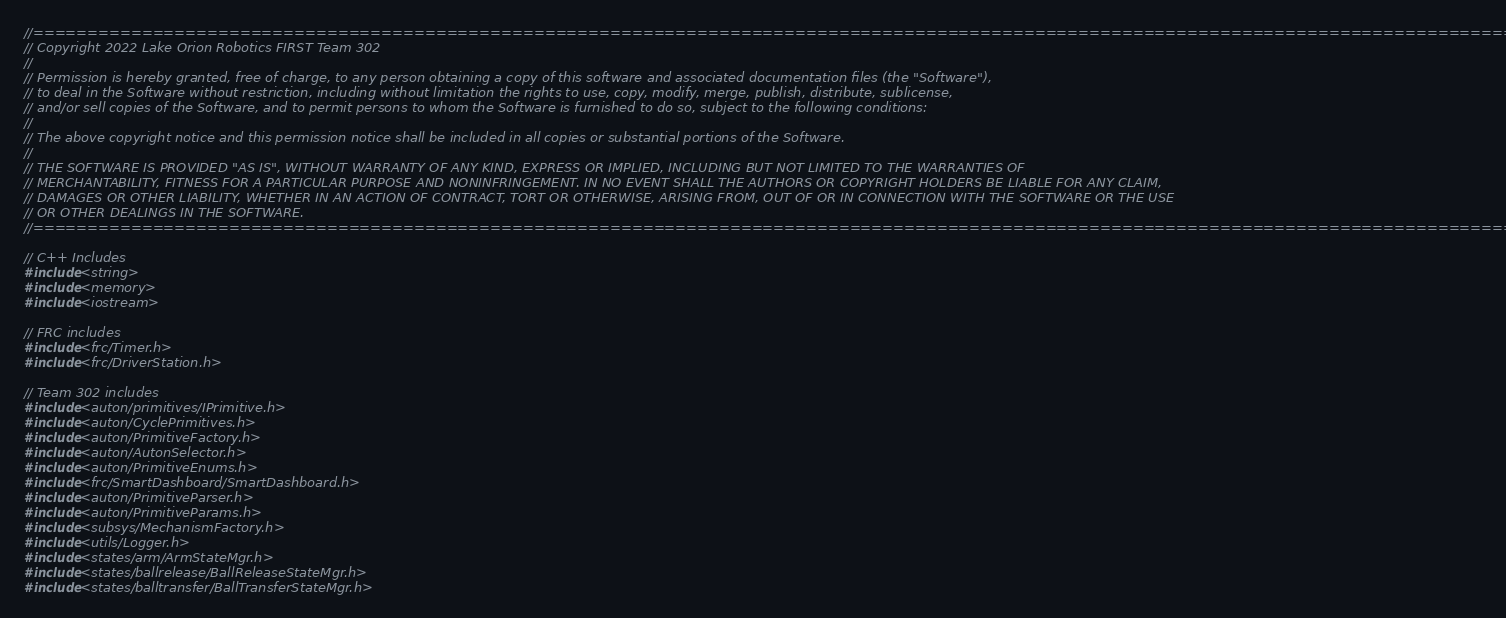Convert code to text. <code><loc_0><loc_0><loc_500><loc_500><_C++_>
//====================================================================================================================================================
// Copyright 2022 Lake Orion Robotics FIRST Team 302
//
// Permission is hereby granted, free of charge, to any person obtaining a copy of this software and associated documentation files (the "Software"),
// to deal in the Software without restriction, including without limitation the rights to use, copy, modify, merge, publish, distribute, sublicense,
// and/or sell copies of the Software, and to permit persons to whom the Software is furnished to do so, subject to the following conditions:
//
// The above copyright notice and this permission notice shall be included in all copies or substantial portions of the Software.
//
// THE SOFTWARE IS PROVIDED "AS IS", WITHOUT WARRANTY OF ANY KIND, EXPRESS OR IMPLIED, INCLUDING BUT NOT LIMITED TO THE WARRANTIES OF
// MERCHANTABILITY, FITNESS FOR A PARTICULAR PURPOSE AND NONINFRINGEMENT. IN NO EVENT SHALL THE AUTHORS OR COPYRIGHT HOLDERS BE LIABLE FOR ANY CLAIM,
// DAMAGES OR OTHER LIABILITY, WHETHER IN AN ACTION OF CONTRACT, TORT OR OTHERWISE, ARISING FROM, OUT OF OR IN CONNECTION WITH THE SOFTWARE OR THE USE
// OR OTHER DEALINGS IN THE SOFTWARE.
//====================================================================================================================================================

// C++ Includes
#include <string>
#include <memory>
#include <iostream>

// FRC includes
#include <frc/Timer.h>
#include <frc/DriverStation.h>

// Team 302 includes
#include <auton/primitives/IPrimitive.h>
#include <auton/CyclePrimitives.h>
#include <auton/PrimitiveFactory.h>
#include <auton/AutonSelector.h>
#include <auton/PrimitiveEnums.h>
#include <frc/SmartDashboard/SmartDashboard.h>
#include <auton/PrimitiveParser.h>
#include <auton/PrimitiveParams.h>
#include <subsys/MechanismFactory.h>
#include <utils/Logger.h>
#include <states/arm/ArmStateMgr.h>
#include <states/ballrelease/BallReleaseStateMgr.h>
#include <states/balltransfer/BallTransferStateMgr.h></code> 